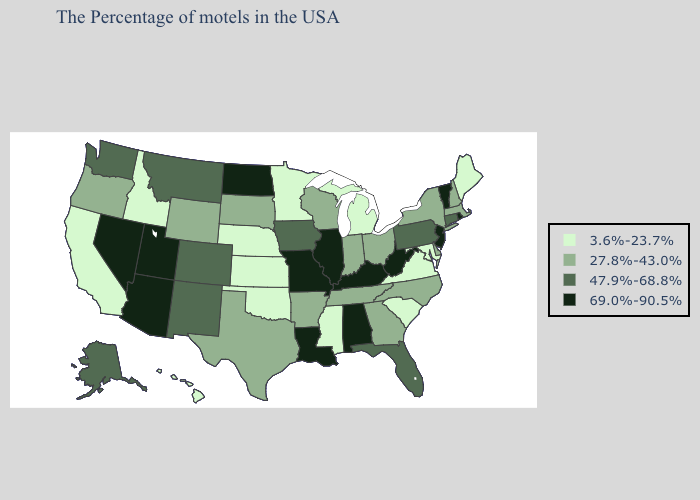Among the states that border Nevada , which have the lowest value?
Write a very short answer. Idaho, California. Does Iowa have the lowest value in the USA?
Be succinct. No. Does Nevada have the lowest value in the West?
Give a very brief answer. No. Name the states that have a value in the range 47.9%-68.8%?
Short answer required. Connecticut, Pennsylvania, Florida, Iowa, Colorado, New Mexico, Montana, Washington, Alaska. What is the value of Arizona?
Give a very brief answer. 69.0%-90.5%. Does the first symbol in the legend represent the smallest category?
Concise answer only. Yes. What is the lowest value in the West?
Keep it brief. 3.6%-23.7%. What is the value of Arizona?
Keep it brief. 69.0%-90.5%. Among the states that border Georgia , which have the highest value?
Give a very brief answer. Alabama. What is the value of Maine?
Write a very short answer. 3.6%-23.7%. Name the states that have a value in the range 69.0%-90.5%?
Keep it brief. Rhode Island, Vermont, New Jersey, West Virginia, Kentucky, Alabama, Illinois, Louisiana, Missouri, North Dakota, Utah, Arizona, Nevada. What is the value of New Jersey?
Answer briefly. 69.0%-90.5%. What is the value of South Carolina?
Answer briefly. 3.6%-23.7%. What is the value of Colorado?
Answer briefly. 47.9%-68.8%. What is the lowest value in the South?
Concise answer only. 3.6%-23.7%. 